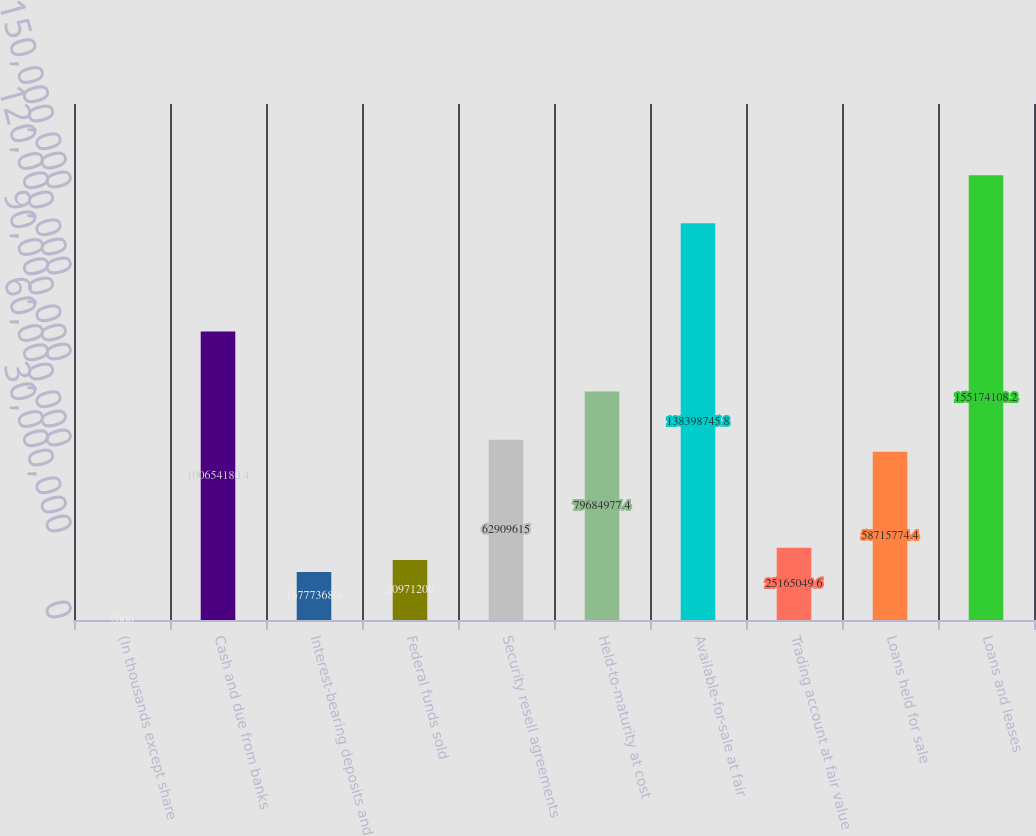Convert chart. <chart><loc_0><loc_0><loc_500><loc_500><bar_chart><fcel>(In thousands except share<fcel>Cash and due from banks<fcel>Interest-bearing deposits and<fcel>Federal funds sold<fcel>Security resell agreements<fcel>Held-to-maturity at cost<fcel>Available-for-sale at fair<fcel>Trading account at fair value<fcel>Loans held for sale<fcel>Loans and leases<nl><fcel>2006<fcel>1.00654e+08<fcel>1.67774e+07<fcel>2.09712e+07<fcel>6.29096e+07<fcel>7.9685e+07<fcel>1.38399e+08<fcel>2.5165e+07<fcel>5.87158e+07<fcel>1.55174e+08<nl></chart> 